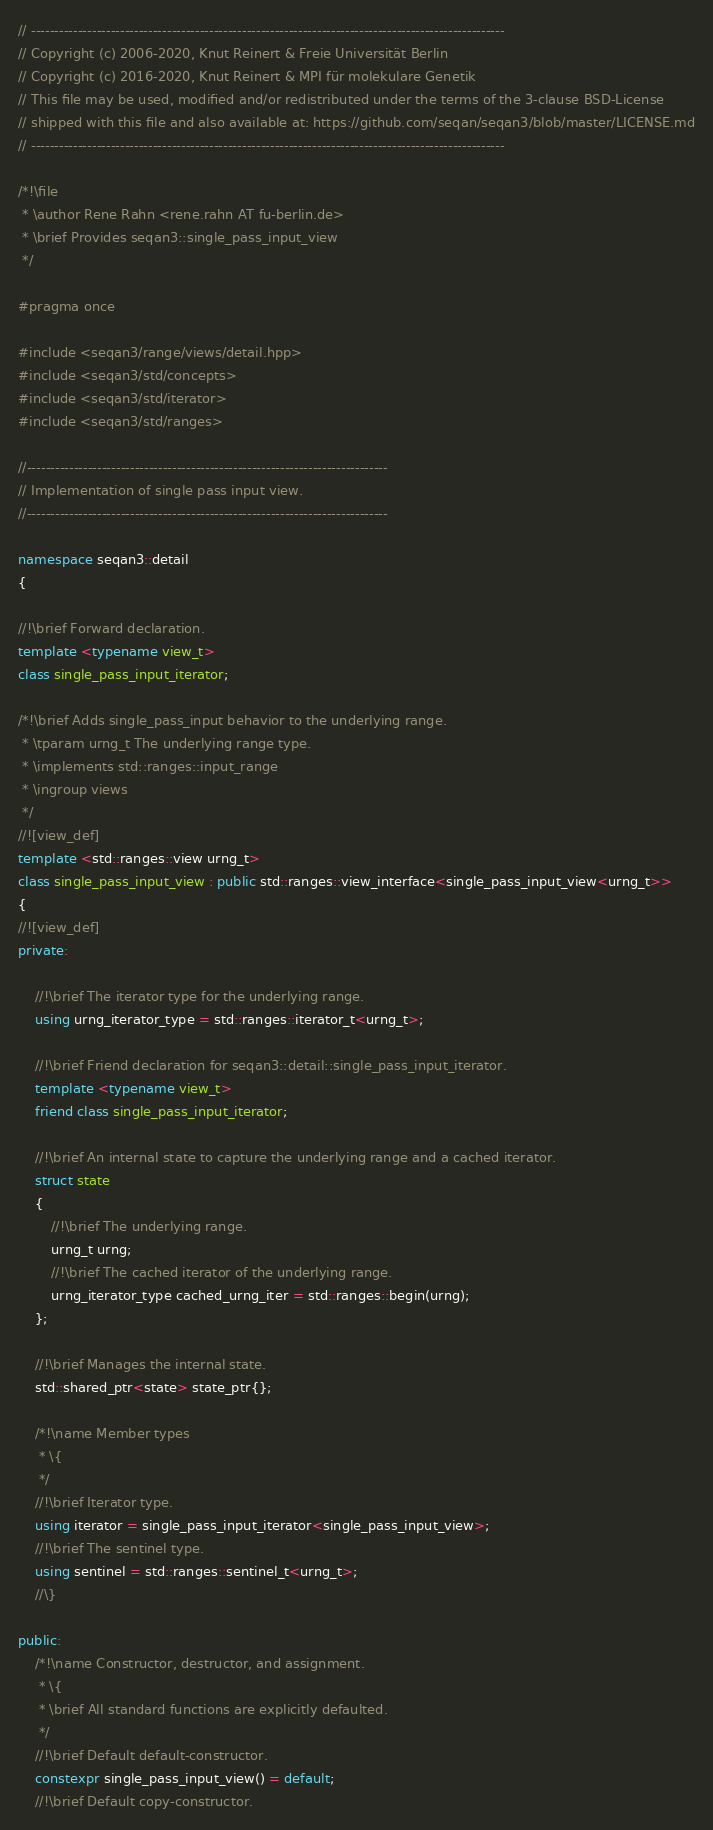<code> <loc_0><loc_0><loc_500><loc_500><_C++_>// -----------------------------------------------------------------------------------------------------
// Copyright (c) 2006-2020, Knut Reinert & Freie Universität Berlin
// Copyright (c) 2016-2020, Knut Reinert & MPI für molekulare Genetik
// This file may be used, modified and/or redistributed under the terms of the 3-clause BSD-License
// shipped with this file and also available at: https://github.com/seqan/seqan3/blob/master/LICENSE.md
// -----------------------------------------------------------------------------------------------------

/*!\file
 * \author Rene Rahn <rene.rahn AT fu-berlin.de>
 * \brief Provides seqan3::single_pass_input_view
 */

#pragma once

#include <seqan3/range/views/detail.hpp>
#include <seqan3/std/concepts>
#include <seqan3/std/iterator>
#include <seqan3/std/ranges>

//-----------------------------------------------------------------------------
// Implementation of single pass input view.
//-----------------------------------------------------------------------------

namespace seqan3::detail
{

//!\brief Forward declaration.
template <typename view_t>
class single_pass_input_iterator;

/*!\brief Adds single_pass_input behavior to the underlying range.
 * \tparam urng_t The underlying range type.
 * \implements std::ranges::input_range
 * \ingroup views
 */
//![view_def]
template <std::ranges::view urng_t>
class single_pass_input_view : public std::ranges::view_interface<single_pass_input_view<urng_t>>
{
//![view_def]
private:

    //!\brief The iterator type for the underlying range.
    using urng_iterator_type = std::ranges::iterator_t<urng_t>;

    //!\brief Friend declaration for seqan3::detail::single_pass_input_iterator.
    template <typename view_t>
    friend class single_pass_input_iterator;

    //!\brief An internal state to capture the underlying range and a cached iterator.
    struct state
    {
        //!\brief The underlying range.
        urng_t urng;
        //!\brief The cached iterator of the underlying range.
        urng_iterator_type cached_urng_iter = std::ranges::begin(urng);
    };

    //!\brief Manages the internal state.
    std::shared_ptr<state> state_ptr{};

    /*!\name Member types
     * \{
     */
    //!\brief Iterator type.
    using iterator = single_pass_input_iterator<single_pass_input_view>;
    //!\brief The sentinel type.
    using sentinel = std::ranges::sentinel_t<urng_t>;
    //\}

public:
    /*!\name Constructor, destructor, and assignment.
     * \{
     * \brief All standard functions are explicitly defaulted.
     */
    //!\brief Default default-constructor.
    constexpr single_pass_input_view() = default;
    //!\brief Default copy-constructor.</code> 